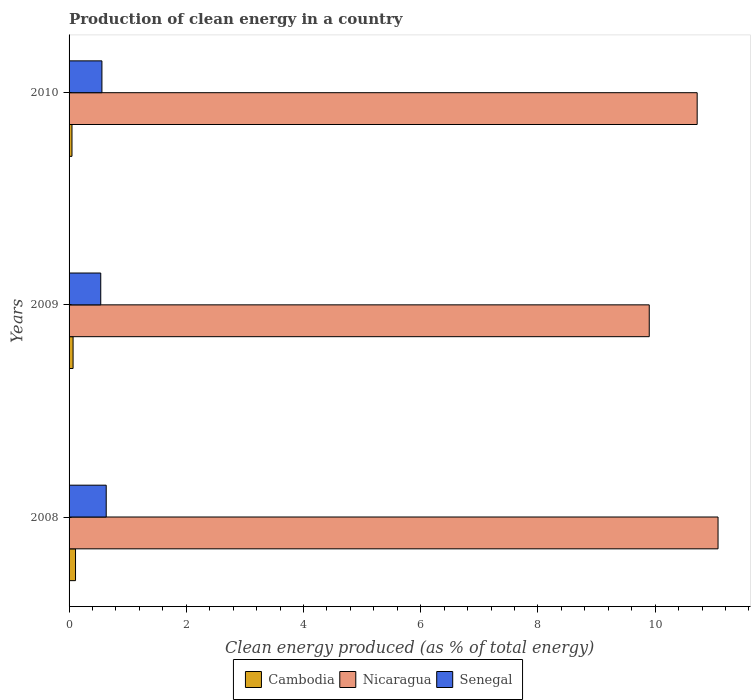How many different coloured bars are there?
Provide a succinct answer. 3. How many groups of bars are there?
Offer a terse response. 3. How many bars are there on the 1st tick from the top?
Offer a very short reply. 3. What is the label of the 1st group of bars from the top?
Make the answer very short. 2010. What is the percentage of clean energy produced in Cambodia in 2010?
Make the answer very short. 0.05. Across all years, what is the maximum percentage of clean energy produced in Nicaragua?
Ensure brevity in your answer.  11.07. Across all years, what is the minimum percentage of clean energy produced in Nicaragua?
Keep it short and to the point. 9.9. What is the total percentage of clean energy produced in Cambodia in the graph?
Keep it short and to the point. 0.23. What is the difference between the percentage of clean energy produced in Nicaragua in 2008 and that in 2009?
Give a very brief answer. 1.17. What is the difference between the percentage of clean energy produced in Senegal in 2010 and the percentage of clean energy produced in Nicaragua in 2009?
Make the answer very short. -9.34. What is the average percentage of clean energy produced in Cambodia per year?
Offer a very short reply. 0.08. In the year 2008, what is the difference between the percentage of clean energy produced in Cambodia and percentage of clean energy produced in Senegal?
Your answer should be very brief. -0.52. In how many years, is the percentage of clean energy produced in Cambodia greater than 11.2 %?
Your response must be concise. 0. What is the ratio of the percentage of clean energy produced in Senegal in 2008 to that in 2009?
Offer a terse response. 1.17. Is the percentage of clean energy produced in Cambodia in 2009 less than that in 2010?
Ensure brevity in your answer.  No. What is the difference between the highest and the second highest percentage of clean energy produced in Nicaragua?
Offer a terse response. 0.36. What is the difference between the highest and the lowest percentage of clean energy produced in Nicaragua?
Make the answer very short. 1.17. Is the sum of the percentage of clean energy produced in Senegal in 2008 and 2009 greater than the maximum percentage of clean energy produced in Nicaragua across all years?
Ensure brevity in your answer.  No. What does the 3rd bar from the top in 2009 represents?
Your answer should be compact. Cambodia. What does the 1st bar from the bottom in 2008 represents?
Ensure brevity in your answer.  Cambodia. Is it the case that in every year, the sum of the percentage of clean energy produced in Nicaragua and percentage of clean energy produced in Cambodia is greater than the percentage of clean energy produced in Senegal?
Your answer should be compact. Yes. How many bars are there?
Provide a succinct answer. 9. Are all the bars in the graph horizontal?
Your answer should be compact. Yes. How many years are there in the graph?
Keep it short and to the point. 3. What is the difference between two consecutive major ticks on the X-axis?
Provide a succinct answer. 2. Are the values on the major ticks of X-axis written in scientific E-notation?
Offer a very short reply. No. Does the graph contain grids?
Provide a short and direct response. No. How are the legend labels stacked?
Your answer should be very brief. Horizontal. What is the title of the graph?
Provide a short and direct response. Production of clean energy in a country. What is the label or title of the X-axis?
Your response must be concise. Clean energy produced (as % of total energy). What is the Clean energy produced (as % of total energy) in Cambodia in 2008?
Provide a short and direct response. 0.11. What is the Clean energy produced (as % of total energy) in Nicaragua in 2008?
Your answer should be compact. 11.07. What is the Clean energy produced (as % of total energy) in Senegal in 2008?
Provide a succinct answer. 0.63. What is the Clean energy produced (as % of total energy) of Cambodia in 2009?
Your answer should be very brief. 0.07. What is the Clean energy produced (as % of total energy) in Nicaragua in 2009?
Your response must be concise. 9.9. What is the Clean energy produced (as % of total energy) of Senegal in 2009?
Your response must be concise. 0.54. What is the Clean energy produced (as % of total energy) in Cambodia in 2010?
Make the answer very short. 0.05. What is the Clean energy produced (as % of total energy) in Nicaragua in 2010?
Make the answer very short. 10.72. What is the Clean energy produced (as % of total energy) in Senegal in 2010?
Offer a very short reply. 0.56. Across all years, what is the maximum Clean energy produced (as % of total energy) of Cambodia?
Keep it short and to the point. 0.11. Across all years, what is the maximum Clean energy produced (as % of total energy) of Nicaragua?
Provide a succinct answer. 11.07. Across all years, what is the maximum Clean energy produced (as % of total energy) of Senegal?
Provide a succinct answer. 0.63. Across all years, what is the minimum Clean energy produced (as % of total energy) in Cambodia?
Offer a very short reply. 0.05. Across all years, what is the minimum Clean energy produced (as % of total energy) of Nicaragua?
Offer a terse response. 9.9. Across all years, what is the minimum Clean energy produced (as % of total energy) in Senegal?
Your answer should be compact. 0.54. What is the total Clean energy produced (as % of total energy) of Cambodia in the graph?
Your response must be concise. 0.23. What is the total Clean energy produced (as % of total energy) of Nicaragua in the graph?
Keep it short and to the point. 31.69. What is the total Clean energy produced (as % of total energy) in Senegal in the graph?
Make the answer very short. 1.73. What is the difference between the Clean energy produced (as % of total energy) in Cambodia in 2008 and that in 2009?
Keep it short and to the point. 0.04. What is the difference between the Clean energy produced (as % of total energy) in Nicaragua in 2008 and that in 2009?
Provide a succinct answer. 1.17. What is the difference between the Clean energy produced (as % of total energy) of Senegal in 2008 and that in 2009?
Provide a short and direct response. 0.09. What is the difference between the Clean energy produced (as % of total energy) in Cambodia in 2008 and that in 2010?
Provide a succinct answer. 0.06. What is the difference between the Clean energy produced (as % of total energy) of Nicaragua in 2008 and that in 2010?
Provide a short and direct response. 0.36. What is the difference between the Clean energy produced (as % of total energy) in Senegal in 2008 and that in 2010?
Keep it short and to the point. 0.07. What is the difference between the Clean energy produced (as % of total energy) of Cambodia in 2009 and that in 2010?
Keep it short and to the point. 0.02. What is the difference between the Clean energy produced (as % of total energy) in Nicaragua in 2009 and that in 2010?
Ensure brevity in your answer.  -0.82. What is the difference between the Clean energy produced (as % of total energy) of Senegal in 2009 and that in 2010?
Offer a very short reply. -0.02. What is the difference between the Clean energy produced (as % of total energy) in Cambodia in 2008 and the Clean energy produced (as % of total energy) in Nicaragua in 2009?
Make the answer very short. -9.79. What is the difference between the Clean energy produced (as % of total energy) in Cambodia in 2008 and the Clean energy produced (as % of total energy) in Senegal in 2009?
Your answer should be compact. -0.43. What is the difference between the Clean energy produced (as % of total energy) in Nicaragua in 2008 and the Clean energy produced (as % of total energy) in Senegal in 2009?
Provide a short and direct response. 10.53. What is the difference between the Clean energy produced (as % of total energy) in Cambodia in 2008 and the Clean energy produced (as % of total energy) in Nicaragua in 2010?
Your answer should be compact. -10.61. What is the difference between the Clean energy produced (as % of total energy) of Cambodia in 2008 and the Clean energy produced (as % of total energy) of Senegal in 2010?
Keep it short and to the point. -0.45. What is the difference between the Clean energy produced (as % of total energy) of Nicaragua in 2008 and the Clean energy produced (as % of total energy) of Senegal in 2010?
Your answer should be very brief. 10.51. What is the difference between the Clean energy produced (as % of total energy) in Cambodia in 2009 and the Clean energy produced (as % of total energy) in Nicaragua in 2010?
Keep it short and to the point. -10.65. What is the difference between the Clean energy produced (as % of total energy) in Cambodia in 2009 and the Clean energy produced (as % of total energy) in Senegal in 2010?
Provide a short and direct response. -0.49. What is the difference between the Clean energy produced (as % of total energy) of Nicaragua in 2009 and the Clean energy produced (as % of total energy) of Senegal in 2010?
Your answer should be compact. 9.34. What is the average Clean energy produced (as % of total energy) in Cambodia per year?
Your answer should be compact. 0.08. What is the average Clean energy produced (as % of total energy) in Nicaragua per year?
Your response must be concise. 10.56. What is the average Clean energy produced (as % of total energy) of Senegal per year?
Give a very brief answer. 0.58. In the year 2008, what is the difference between the Clean energy produced (as % of total energy) of Cambodia and Clean energy produced (as % of total energy) of Nicaragua?
Your answer should be compact. -10.96. In the year 2008, what is the difference between the Clean energy produced (as % of total energy) of Cambodia and Clean energy produced (as % of total energy) of Senegal?
Give a very brief answer. -0.52. In the year 2008, what is the difference between the Clean energy produced (as % of total energy) of Nicaragua and Clean energy produced (as % of total energy) of Senegal?
Ensure brevity in your answer.  10.44. In the year 2009, what is the difference between the Clean energy produced (as % of total energy) in Cambodia and Clean energy produced (as % of total energy) in Nicaragua?
Provide a succinct answer. -9.83. In the year 2009, what is the difference between the Clean energy produced (as % of total energy) of Cambodia and Clean energy produced (as % of total energy) of Senegal?
Your answer should be very brief. -0.47. In the year 2009, what is the difference between the Clean energy produced (as % of total energy) in Nicaragua and Clean energy produced (as % of total energy) in Senegal?
Your answer should be compact. 9.36. In the year 2010, what is the difference between the Clean energy produced (as % of total energy) in Cambodia and Clean energy produced (as % of total energy) in Nicaragua?
Your response must be concise. -10.67. In the year 2010, what is the difference between the Clean energy produced (as % of total energy) in Cambodia and Clean energy produced (as % of total energy) in Senegal?
Provide a short and direct response. -0.51. In the year 2010, what is the difference between the Clean energy produced (as % of total energy) of Nicaragua and Clean energy produced (as % of total energy) of Senegal?
Provide a short and direct response. 10.16. What is the ratio of the Clean energy produced (as % of total energy) of Cambodia in 2008 to that in 2009?
Give a very brief answer. 1.61. What is the ratio of the Clean energy produced (as % of total energy) of Nicaragua in 2008 to that in 2009?
Your answer should be compact. 1.12. What is the ratio of the Clean energy produced (as % of total energy) of Senegal in 2008 to that in 2009?
Your answer should be very brief. 1.17. What is the ratio of the Clean energy produced (as % of total energy) of Cambodia in 2008 to that in 2010?
Keep it short and to the point. 2.22. What is the ratio of the Clean energy produced (as % of total energy) in Nicaragua in 2008 to that in 2010?
Give a very brief answer. 1.03. What is the ratio of the Clean energy produced (as % of total energy) in Senegal in 2008 to that in 2010?
Keep it short and to the point. 1.13. What is the ratio of the Clean energy produced (as % of total energy) of Cambodia in 2009 to that in 2010?
Your answer should be compact. 1.38. What is the ratio of the Clean energy produced (as % of total energy) of Nicaragua in 2009 to that in 2010?
Give a very brief answer. 0.92. What is the ratio of the Clean energy produced (as % of total energy) of Senegal in 2009 to that in 2010?
Provide a short and direct response. 0.96. What is the difference between the highest and the second highest Clean energy produced (as % of total energy) of Cambodia?
Offer a very short reply. 0.04. What is the difference between the highest and the second highest Clean energy produced (as % of total energy) in Nicaragua?
Offer a very short reply. 0.36. What is the difference between the highest and the second highest Clean energy produced (as % of total energy) in Senegal?
Your answer should be very brief. 0.07. What is the difference between the highest and the lowest Clean energy produced (as % of total energy) in Cambodia?
Keep it short and to the point. 0.06. What is the difference between the highest and the lowest Clean energy produced (as % of total energy) in Nicaragua?
Your answer should be compact. 1.17. What is the difference between the highest and the lowest Clean energy produced (as % of total energy) of Senegal?
Make the answer very short. 0.09. 